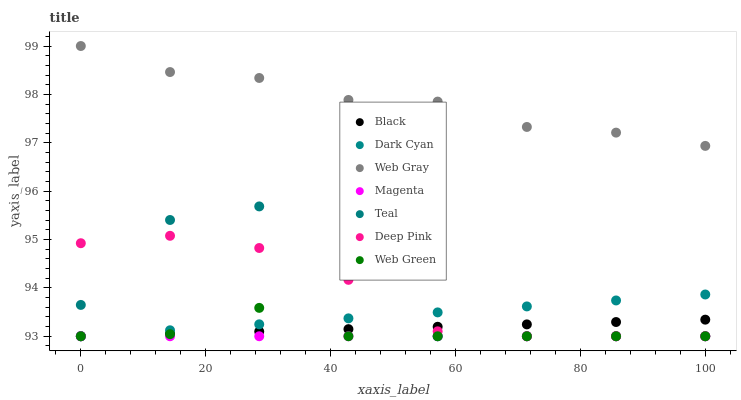Does Magenta have the minimum area under the curve?
Answer yes or no. Yes. Does Web Gray have the maximum area under the curve?
Answer yes or no. Yes. Does Web Green have the minimum area under the curve?
Answer yes or no. No. Does Web Green have the maximum area under the curve?
Answer yes or no. No. Is Magenta the smoothest?
Answer yes or no. Yes. Is Teal the roughest?
Answer yes or no. Yes. Is Web Green the smoothest?
Answer yes or no. No. Is Web Green the roughest?
Answer yes or no. No. Does Web Green have the lowest value?
Answer yes or no. Yes. Does Web Gray have the highest value?
Answer yes or no. Yes. Does Web Green have the highest value?
Answer yes or no. No. Is Magenta less than Web Gray?
Answer yes or no. Yes. Is Web Gray greater than Black?
Answer yes or no. Yes. Does Magenta intersect Dark Cyan?
Answer yes or no. Yes. Is Magenta less than Dark Cyan?
Answer yes or no. No. Is Magenta greater than Dark Cyan?
Answer yes or no. No. Does Magenta intersect Web Gray?
Answer yes or no. No. 